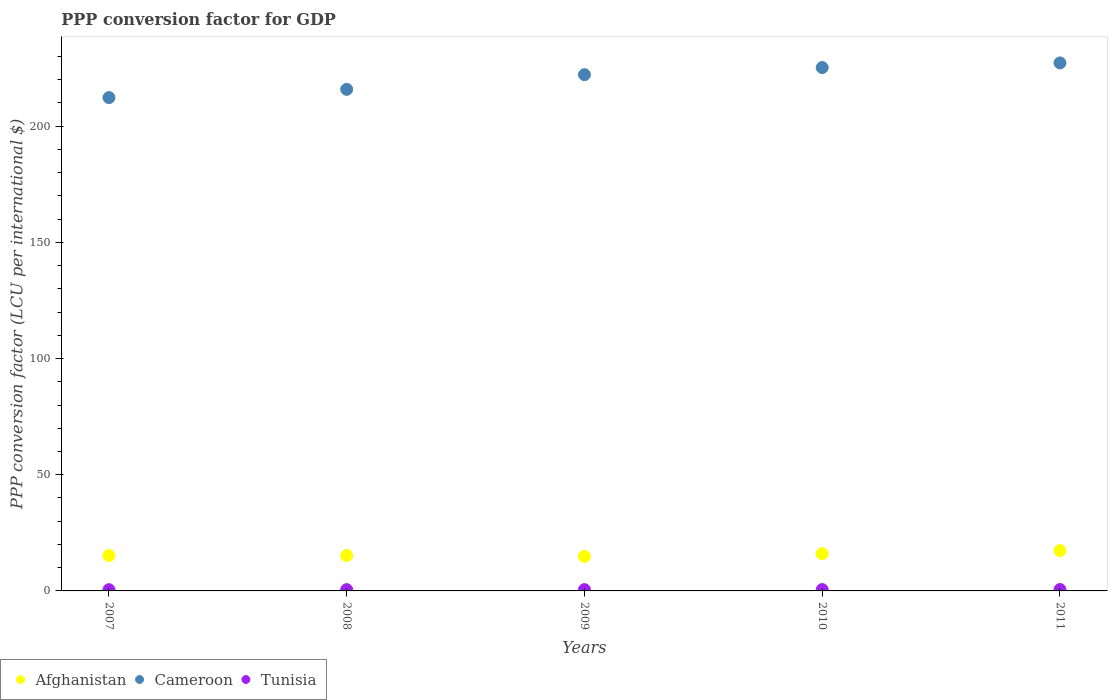How many different coloured dotlines are there?
Give a very brief answer. 3. Is the number of dotlines equal to the number of legend labels?
Your response must be concise. Yes. What is the PPP conversion factor for GDP in Cameroon in 2008?
Your answer should be very brief. 215.84. Across all years, what is the maximum PPP conversion factor for GDP in Afghanistan?
Keep it short and to the point. 17.36. Across all years, what is the minimum PPP conversion factor for GDP in Afghanistan?
Keep it short and to the point. 14.82. What is the total PPP conversion factor for GDP in Cameroon in the graph?
Your answer should be compact. 1102.72. What is the difference between the PPP conversion factor for GDP in Afghanistan in 2008 and that in 2010?
Your response must be concise. -0.77. What is the difference between the PPP conversion factor for GDP in Cameroon in 2011 and the PPP conversion factor for GDP in Tunisia in 2008?
Keep it short and to the point. 226.66. What is the average PPP conversion factor for GDP in Cameroon per year?
Your answer should be very brief. 220.54. In the year 2009, what is the difference between the PPP conversion factor for GDP in Cameroon and PPP conversion factor for GDP in Afghanistan?
Offer a terse response. 207.33. What is the ratio of the PPP conversion factor for GDP in Tunisia in 2009 to that in 2011?
Offer a very short reply. 0.95. Is the PPP conversion factor for GDP in Tunisia in 2008 less than that in 2011?
Offer a very short reply. Yes. What is the difference between the highest and the second highest PPP conversion factor for GDP in Tunisia?
Ensure brevity in your answer.  0.01. What is the difference between the highest and the lowest PPP conversion factor for GDP in Afghanistan?
Offer a terse response. 2.54. In how many years, is the PPP conversion factor for GDP in Afghanistan greater than the average PPP conversion factor for GDP in Afghanistan taken over all years?
Keep it short and to the point. 2. Is the PPP conversion factor for GDP in Tunisia strictly greater than the PPP conversion factor for GDP in Cameroon over the years?
Provide a succinct answer. No. Is the PPP conversion factor for GDP in Tunisia strictly less than the PPP conversion factor for GDP in Cameroon over the years?
Offer a terse response. Yes. Are the values on the major ticks of Y-axis written in scientific E-notation?
Make the answer very short. No. Does the graph contain any zero values?
Give a very brief answer. No. Where does the legend appear in the graph?
Offer a terse response. Bottom left. How many legend labels are there?
Offer a terse response. 3. What is the title of the graph?
Your answer should be very brief. PPP conversion factor for GDP. Does "Finland" appear as one of the legend labels in the graph?
Offer a terse response. No. What is the label or title of the X-axis?
Provide a short and direct response. Years. What is the label or title of the Y-axis?
Offer a terse response. PPP conversion factor (LCU per international $). What is the PPP conversion factor (LCU per international $) of Afghanistan in 2007?
Offer a very short reply. 15.22. What is the PPP conversion factor (LCU per international $) of Cameroon in 2007?
Keep it short and to the point. 212.29. What is the PPP conversion factor (LCU per international $) in Tunisia in 2007?
Provide a succinct answer. 0.53. What is the PPP conversion factor (LCU per international $) of Afghanistan in 2008?
Provide a short and direct response. 15.25. What is the PPP conversion factor (LCU per international $) in Cameroon in 2008?
Your answer should be compact. 215.84. What is the PPP conversion factor (LCU per international $) of Tunisia in 2008?
Provide a short and direct response. 0.55. What is the PPP conversion factor (LCU per international $) in Afghanistan in 2009?
Provide a succinct answer. 14.82. What is the PPP conversion factor (LCU per international $) of Cameroon in 2009?
Provide a short and direct response. 222.15. What is the PPP conversion factor (LCU per international $) in Tunisia in 2009?
Provide a short and direct response. 0.56. What is the PPP conversion factor (LCU per international $) in Afghanistan in 2010?
Keep it short and to the point. 16.02. What is the PPP conversion factor (LCU per international $) of Cameroon in 2010?
Your answer should be very brief. 225.22. What is the PPP conversion factor (LCU per international $) of Tunisia in 2010?
Your response must be concise. 0.58. What is the PPP conversion factor (LCU per international $) in Afghanistan in 2011?
Your answer should be very brief. 17.36. What is the PPP conversion factor (LCU per international $) in Cameroon in 2011?
Keep it short and to the point. 227.21. What is the PPP conversion factor (LCU per international $) in Tunisia in 2011?
Your answer should be very brief. 0.59. Across all years, what is the maximum PPP conversion factor (LCU per international $) in Afghanistan?
Give a very brief answer. 17.36. Across all years, what is the maximum PPP conversion factor (LCU per international $) in Cameroon?
Make the answer very short. 227.21. Across all years, what is the maximum PPP conversion factor (LCU per international $) of Tunisia?
Offer a terse response. 0.59. Across all years, what is the minimum PPP conversion factor (LCU per international $) of Afghanistan?
Give a very brief answer. 14.82. Across all years, what is the minimum PPP conversion factor (LCU per international $) in Cameroon?
Your answer should be very brief. 212.29. Across all years, what is the minimum PPP conversion factor (LCU per international $) of Tunisia?
Offer a terse response. 0.53. What is the total PPP conversion factor (LCU per international $) in Afghanistan in the graph?
Your answer should be compact. 78.67. What is the total PPP conversion factor (LCU per international $) in Cameroon in the graph?
Ensure brevity in your answer.  1102.72. What is the total PPP conversion factor (LCU per international $) of Tunisia in the graph?
Give a very brief answer. 2.82. What is the difference between the PPP conversion factor (LCU per international $) of Afghanistan in 2007 and that in 2008?
Offer a terse response. -0.03. What is the difference between the PPP conversion factor (LCU per international $) of Cameroon in 2007 and that in 2008?
Ensure brevity in your answer.  -3.54. What is the difference between the PPP conversion factor (LCU per international $) of Tunisia in 2007 and that in 2008?
Keep it short and to the point. -0.02. What is the difference between the PPP conversion factor (LCU per international $) of Afghanistan in 2007 and that in 2009?
Keep it short and to the point. 0.4. What is the difference between the PPP conversion factor (LCU per international $) of Cameroon in 2007 and that in 2009?
Your response must be concise. -9.86. What is the difference between the PPP conversion factor (LCU per international $) of Tunisia in 2007 and that in 2009?
Your answer should be very brief. -0.04. What is the difference between the PPP conversion factor (LCU per international $) in Afghanistan in 2007 and that in 2010?
Offer a terse response. -0.8. What is the difference between the PPP conversion factor (LCU per international $) in Cameroon in 2007 and that in 2010?
Offer a terse response. -12.93. What is the difference between the PPP conversion factor (LCU per international $) in Tunisia in 2007 and that in 2010?
Provide a succinct answer. -0.05. What is the difference between the PPP conversion factor (LCU per international $) in Afghanistan in 2007 and that in 2011?
Your response must be concise. -2.14. What is the difference between the PPP conversion factor (LCU per international $) of Cameroon in 2007 and that in 2011?
Provide a short and direct response. -14.92. What is the difference between the PPP conversion factor (LCU per international $) of Tunisia in 2007 and that in 2011?
Offer a very short reply. -0.06. What is the difference between the PPP conversion factor (LCU per international $) in Afghanistan in 2008 and that in 2009?
Offer a very short reply. 0.43. What is the difference between the PPP conversion factor (LCU per international $) in Cameroon in 2008 and that in 2009?
Offer a terse response. -6.31. What is the difference between the PPP conversion factor (LCU per international $) in Tunisia in 2008 and that in 2009?
Ensure brevity in your answer.  -0.01. What is the difference between the PPP conversion factor (LCU per international $) in Afghanistan in 2008 and that in 2010?
Your response must be concise. -0.77. What is the difference between the PPP conversion factor (LCU per international $) in Cameroon in 2008 and that in 2010?
Give a very brief answer. -9.38. What is the difference between the PPP conversion factor (LCU per international $) in Tunisia in 2008 and that in 2010?
Provide a succinct answer. -0.03. What is the difference between the PPP conversion factor (LCU per international $) of Afghanistan in 2008 and that in 2011?
Provide a succinct answer. -2.1. What is the difference between the PPP conversion factor (LCU per international $) in Cameroon in 2008 and that in 2011?
Your answer should be compact. -11.37. What is the difference between the PPP conversion factor (LCU per international $) in Tunisia in 2008 and that in 2011?
Make the answer very short. -0.04. What is the difference between the PPP conversion factor (LCU per international $) in Afghanistan in 2009 and that in 2010?
Provide a succinct answer. -1.2. What is the difference between the PPP conversion factor (LCU per international $) of Cameroon in 2009 and that in 2010?
Provide a succinct answer. -3.07. What is the difference between the PPP conversion factor (LCU per international $) in Tunisia in 2009 and that in 2010?
Provide a short and direct response. -0.01. What is the difference between the PPP conversion factor (LCU per international $) of Afghanistan in 2009 and that in 2011?
Offer a terse response. -2.54. What is the difference between the PPP conversion factor (LCU per international $) of Cameroon in 2009 and that in 2011?
Ensure brevity in your answer.  -5.06. What is the difference between the PPP conversion factor (LCU per international $) of Tunisia in 2009 and that in 2011?
Your answer should be very brief. -0.03. What is the difference between the PPP conversion factor (LCU per international $) of Afghanistan in 2010 and that in 2011?
Your response must be concise. -1.33. What is the difference between the PPP conversion factor (LCU per international $) of Cameroon in 2010 and that in 2011?
Give a very brief answer. -1.99. What is the difference between the PPP conversion factor (LCU per international $) in Tunisia in 2010 and that in 2011?
Offer a very short reply. -0.01. What is the difference between the PPP conversion factor (LCU per international $) in Afghanistan in 2007 and the PPP conversion factor (LCU per international $) in Cameroon in 2008?
Provide a short and direct response. -200.62. What is the difference between the PPP conversion factor (LCU per international $) of Afghanistan in 2007 and the PPP conversion factor (LCU per international $) of Tunisia in 2008?
Your answer should be very brief. 14.67. What is the difference between the PPP conversion factor (LCU per international $) of Cameroon in 2007 and the PPP conversion factor (LCU per international $) of Tunisia in 2008?
Your response must be concise. 211.74. What is the difference between the PPP conversion factor (LCU per international $) of Afghanistan in 2007 and the PPP conversion factor (LCU per international $) of Cameroon in 2009?
Your answer should be very brief. -206.93. What is the difference between the PPP conversion factor (LCU per international $) in Afghanistan in 2007 and the PPP conversion factor (LCU per international $) in Tunisia in 2009?
Make the answer very short. 14.66. What is the difference between the PPP conversion factor (LCU per international $) of Cameroon in 2007 and the PPP conversion factor (LCU per international $) of Tunisia in 2009?
Your answer should be very brief. 211.73. What is the difference between the PPP conversion factor (LCU per international $) of Afghanistan in 2007 and the PPP conversion factor (LCU per international $) of Cameroon in 2010?
Provide a short and direct response. -210. What is the difference between the PPP conversion factor (LCU per international $) in Afghanistan in 2007 and the PPP conversion factor (LCU per international $) in Tunisia in 2010?
Offer a terse response. 14.64. What is the difference between the PPP conversion factor (LCU per international $) in Cameroon in 2007 and the PPP conversion factor (LCU per international $) in Tunisia in 2010?
Provide a succinct answer. 211.72. What is the difference between the PPP conversion factor (LCU per international $) in Afghanistan in 2007 and the PPP conversion factor (LCU per international $) in Cameroon in 2011?
Make the answer very short. -211.99. What is the difference between the PPP conversion factor (LCU per international $) of Afghanistan in 2007 and the PPP conversion factor (LCU per international $) of Tunisia in 2011?
Provide a succinct answer. 14.63. What is the difference between the PPP conversion factor (LCU per international $) of Cameroon in 2007 and the PPP conversion factor (LCU per international $) of Tunisia in 2011?
Offer a very short reply. 211.7. What is the difference between the PPP conversion factor (LCU per international $) in Afghanistan in 2008 and the PPP conversion factor (LCU per international $) in Cameroon in 2009?
Give a very brief answer. -206.9. What is the difference between the PPP conversion factor (LCU per international $) of Afghanistan in 2008 and the PPP conversion factor (LCU per international $) of Tunisia in 2009?
Offer a terse response. 14.69. What is the difference between the PPP conversion factor (LCU per international $) in Cameroon in 2008 and the PPP conversion factor (LCU per international $) in Tunisia in 2009?
Provide a short and direct response. 215.27. What is the difference between the PPP conversion factor (LCU per international $) in Afghanistan in 2008 and the PPP conversion factor (LCU per international $) in Cameroon in 2010?
Keep it short and to the point. -209.97. What is the difference between the PPP conversion factor (LCU per international $) of Afghanistan in 2008 and the PPP conversion factor (LCU per international $) of Tunisia in 2010?
Your answer should be very brief. 14.67. What is the difference between the PPP conversion factor (LCU per international $) in Cameroon in 2008 and the PPP conversion factor (LCU per international $) in Tunisia in 2010?
Ensure brevity in your answer.  215.26. What is the difference between the PPP conversion factor (LCU per international $) in Afghanistan in 2008 and the PPP conversion factor (LCU per international $) in Cameroon in 2011?
Provide a succinct answer. -211.96. What is the difference between the PPP conversion factor (LCU per international $) in Afghanistan in 2008 and the PPP conversion factor (LCU per international $) in Tunisia in 2011?
Offer a terse response. 14.66. What is the difference between the PPP conversion factor (LCU per international $) in Cameroon in 2008 and the PPP conversion factor (LCU per international $) in Tunisia in 2011?
Offer a very short reply. 215.25. What is the difference between the PPP conversion factor (LCU per international $) in Afghanistan in 2009 and the PPP conversion factor (LCU per international $) in Cameroon in 2010?
Keep it short and to the point. -210.4. What is the difference between the PPP conversion factor (LCU per international $) in Afghanistan in 2009 and the PPP conversion factor (LCU per international $) in Tunisia in 2010?
Ensure brevity in your answer.  14.24. What is the difference between the PPP conversion factor (LCU per international $) of Cameroon in 2009 and the PPP conversion factor (LCU per international $) of Tunisia in 2010?
Offer a very short reply. 221.57. What is the difference between the PPP conversion factor (LCU per international $) of Afghanistan in 2009 and the PPP conversion factor (LCU per international $) of Cameroon in 2011?
Ensure brevity in your answer.  -212.39. What is the difference between the PPP conversion factor (LCU per international $) in Afghanistan in 2009 and the PPP conversion factor (LCU per international $) in Tunisia in 2011?
Make the answer very short. 14.23. What is the difference between the PPP conversion factor (LCU per international $) of Cameroon in 2009 and the PPP conversion factor (LCU per international $) of Tunisia in 2011?
Provide a succinct answer. 221.56. What is the difference between the PPP conversion factor (LCU per international $) in Afghanistan in 2010 and the PPP conversion factor (LCU per international $) in Cameroon in 2011?
Give a very brief answer. -211.19. What is the difference between the PPP conversion factor (LCU per international $) of Afghanistan in 2010 and the PPP conversion factor (LCU per international $) of Tunisia in 2011?
Ensure brevity in your answer.  15.43. What is the difference between the PPP conversion factor (LCU per international $) of Cameroon in 2010 and the PPP conversion factor (LCU per international $) of Tunisia in 2011?
Offer a very short reply. 224.63. What is the average PPP conversion factor (LCU per international $) of Afghanistan per year?
Keep it short and to the point. 15.73. What is the average PPP conversion factor (LCU per international $) of Cameroon per year?
Give a very brief answer. 220.54. What is the average PPP conversion factor (LCU per international $) of Tunisia per year?
Provide a succinct answer. 0.56. In the year 2007, what is the difference between the PPP conversion factor (LCU per international $) of Afghanistan and PPP conversion factor (LCU per international $) of Cameroon?
Your answer should be very brief. -197.07. In the year 2007, what is the difference between the PPP conversion factor (LCU per international $) in Afghanistan and PPP conversion factor (LCU per international $) in Tunisia?
Your answer should be very brief. 14.69. In the year 2007, what is the difference between the PPP conversion factor (LCU per international $) in Cameroon and PPP conversion factor (LCU per international $) in Tunisia?
Keep it short and to the point. 211.76. In the year 2008, what is the difference between the PPP conversion factor (LCU per international $) of Afghanistan and PPP conversion factor (LCU per international $) of Cameroon?
Your answer should be compact. -200.59. In the year 2008, what is the difference between the PPP conversion factor (LCU per international $) of Afghanistan and PPP conversion factor (LCU per international $) of Tunisia?
Ensure brevity in your answer.  14.7. In the year 2008, what is the difference between the PPP conversion factor (LCU per international $) in Cameroon and PPP conversion factor (LCU per international $) in Tunisia?
Your response must be concise. 215.29. In the year 2009, what is the difference between the PPP conversion factor (LCU per international $) in Afghanistan and PPP conversion factor (LCU per international $) in Cameroon?
Offer a terse response. -207.33. In the year 2009, what is the difference between the PPP conversion factor (LCU per international $) of Afghanistan and PPP conversion factor (LCU per international $) of Tunisia?
Give a very brief answer. 14.26. In the year 2009, what is the difference between the PPP conversion factor (LCU per international $) of Cameroon and PPP conversion factor (LCU per international $) of Tunisia?
Offer a very short reply. 221.59. In the year 2010, what is the difference between the PPP conversion factor (LCU per international $) of Afghanistan and PPP conversion factor (LCU per international $) of Cameroon?
Make the answer very short. -209.2. In the year 2010, what is the difference between the PPP conversion factor (LCU per international $) in Afghanistan and PPP conversion factor (LCU per international $) in Tunisia?
Ensure brevity in your answer.  15.44. In the year 2010, what is the difference between the PPP conversion factor (LCU per international $) of Cameroon and PPP conversion factor (LCU per international $) of Tunisia?
Your answer should be compact. 224.64. In the year 2011, what is the difference between the PPP conversion factor (LCU per international $) of Afghanistan and PPP conversion factor (LCU per international $) of Cameroon?
Give a very brief answer. -209.86. In the year 2011, what is the difference between the PPP conversion factor (LCU per international $) of Afghanistan and PPP conversion factor (LCU per international $) of Tunisia?
Your answer should be very brief. 16.76. In the year 2011, what is the difference between the PPP conversion factor (LCU per international $) in Cameroon and PPP conversion factor (LCU per international $) in Tunisia?
Provide a short and direct response. 226.62. What is the ratio of the PPP conversion factor (LCU per international $) of Afghanistan in 2007 to that in 2008?
Provide a short and direct response. 1. What is the ratio of the PPP conversion factor (LCU per international $) in Cameroon in 2007 to that in 2008?
Offer a terse response. 0.98. What is the ratio of the PPP conversion factor (LCU per international $) of Tunisia in 2007 to that in 2008?
Provide a succinct answer. 0.96. What is the ratio of the PPP conversion factor (LCU per international $) of Afghanistan in 2007 to that in 2009?
Offer a very short reply. 1.03. What is the ratio of the PPP conversion factor (LCU per international $) in Cameroon in 2007 to that in 2009?
Keep it short and to the point. 0.96. What is the ratio of the PPP conversion factor (LCU per international $) in Tunisia in 2007 to that in 2009?
Your answer should be compact. 0.94. What is the ratio of the PPP conversion factor (LCU per international $) in Afghanistan in 2007 to that in 2010?
Make the answer very short. 0.95. What is the ratio of the PPP conversion factor (LCU per international $) of Cameroon in 2007 to that in 2010?
Offer a very short reply. 0.94. What is the ratio of the PPP conversion factor (LCU per international $) of Tunisia in 2007 to that in 2010?
Your answer should be compact. 0.91. What is the ratio of the PPP conversion factor (LCU per international $) of Afghanistan in 2007 to that in 2011?
Keep it short and to the point. 0.88. What is the ratio of the PPP conversion factor (LCU per international $) of Cameroon in 2007 to that in 2011?
Offer a terse response. 0.93. What is the ratio of the PPP conversion factor (LCU per international $) in Tunisia in 2007 to that in 2011?
Make the answer very short. 0.89. What is the ratio of the PPP conversion factor (LCU per international $) in Afghanistan in 2008 to that in 2009?
Your response must be concise. 1.03. What is the ratio of the PPP conversion factor (LCU per international $) of Cameroon in 2008 to that in 2009?
Provide a succinct answer. 0.97. What is the ratio of the PPP conversion factor (LCU per international $) in Tunisia in 2008 to that in 2009?
Offer a terse response. 0.98. What is the ratio of the PPP conversion factor (LCU per international $) in Tunisia in 2008 to that in 2010?
Keep it short and to the point. 0.95. What is the ratio of the PPP conversion factor (LCU per international $) of Afghanistan in 2008 to that in 2011?
Provide a short and direct response. 0.88. What is the ratio of the PPP conversion factor (LCU per international $) of Cameroon in 2008 to that in 2011?
Make the answer very short. 0.95. What is the ratio of the PPP conversion factor (LCU per international $) of Tunisia in 2008 to that in 2011?
Keep it short and to the point. 0.93. What is the ratio of the PPP conversion factor (LCU per international $) of Afghanistan in 2009 to that in 2010?
Make the answer very short. 0.92. What is the ratio of the PPP conversion factor (LCU per international $) in Cameroon in 2009 to that in 2010?
Your answer should be compact. 0.99. What is the ratio of the PPP conversion factor (LCU per international $) of Tunisia in 2009 to that in 2010?
Ensure brevity in your answer.  0.97. What is the ratio of the PPP conversion factor (LCU per international $) in Afghanistan in 2009 to that in 2011?
Offer a terse response. 0.85. What is the ratio of the PPP conversion factor (LCU per international $) of Cameroon in 2009 to that in 2011?
Your answer should be compact. 0.98. What is the ratio of the PPP conversion factor (LCU per international $) of Tunisia in 2009 to that in 2011?
Your answer should be very brief. 0.95. What is the ratio of the PPP conversion factor (LCU per international $) of Afghanistan in 2010 to that in 2011?
Keep it short and to the point. 0.92. What is the ratio of the PPP conversion factor (LCU per international $) in Cameroon in 2010 to that in 2011?
Ensure brevity in your answer.  0.99. What is the ratio of the PPP conversion factor (LCU per international $) in Tunisia in 2010 to that in 2011?
Give a very brief answer. 0.98. What is the difference between the highest and the second highest PPP conversion factor (LCU per international $) in Afghanistan?
Provide a succinct answer. 1.33. What is the difference between the highest and the second highest PPP conversion factor (LCU per international $) in Cameroon?
Make the answer very short. 1.99. What is the difference between the highest and the second highest PPP conversion factor (LCU per international $) in Tunisia?
Offer a very short reply. 0.01. What is the difference between the highest and the lowest PPP conversion factor (LCU per international $) of Afghanistan?
Your answer should be compact. 2.54. What is the difference between the highest and the lowest PPP conversion factor (LCU per international $) in Cameroon?
Your response must be concise. 14.92. What is the difference between the highest and the lowest PPP conversion factor (LCU per international $) in Tunisia?
Your answer should be compact. 0.06. 